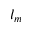Convert formula to latex. <formula><loc_0><loc_0><loc_500><loc_500>l _ { m }</formula> 